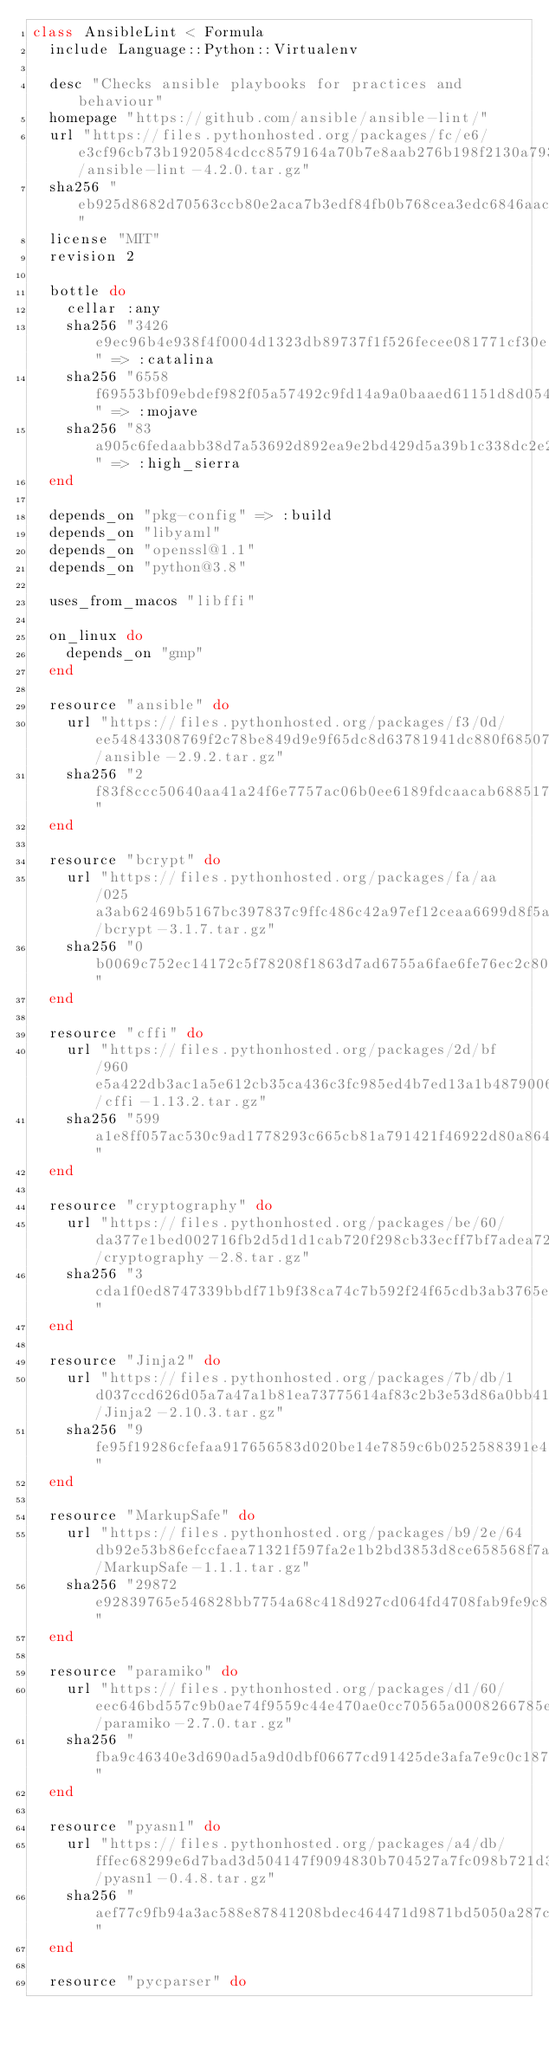Convert code to text. <code><loc_0><loc_0><loc_500><loc_500><_Ruby_>class AnsibleLint < Formula
  include Language::Python::Virtualenv

  desc "Checks ansible playbooks for practices and behaviour"
  homepage "https://github.com/ansible/ansible-lint/"
  url "https://files.pythonhosted.org/packages/fc/e6/e3cf96cb73b1920584cdcc8579164a70b7e8aab276b198f2130a7939efcc/ansible-lint-4.2.0.tar.gz"
  sha256 "eb925d8682d70563ccb80e2aca7b3edf84fb0b768cea3edc6846aac7abdc414a"
  license "MIT"
  revision 2

  bottle do
    cellar :any
    sha256 "3426e9ec96b4e938f4f0004d1323db89737f1f526fecee081771cf30e1689dd7" => :catalina
    sha256 "6558f69553bf09ebdef982f05a57492c9fd14a9a0baaed61151d8d054e652e73" => :mojave
    sha256 "83a905c6fedaabb38d7a53692d892ea9e2bd429d5a39b1c338dc2e26ea0d352f" => :high_sierra
  end

  depends_on "pkg-config" => :build
  depends_on "libyaml"
  depends_on "openssl@1.1"
  depends_on "python@3.8"

  uses_from_macos "libffi"

  on_linux do
    depends_on "gmp"
  end

  resource "ansible" do
    url "https://files.pythonhosted.org/packages/f3/0d/ee54843308769f2c78be849d9e9f65dc8d63781941dc880f68507aae33ba/ansible-2.9.2.tar.gz"
    sha256 "2f83f8ccc50640aa41a24f6e7757ac06b0ee6189fdcaacab68851771d3b42f3a"
  end

  resource "bcrypt" do
    url "https://files.pythonhosted.org/packages/fa/aa/025a3ab62469b5167bc397837c9ffc486c42a97ef12ceaa6699d8f5a5416/bcrypt-3.1.7.tar.gz"
    sha256 "0b0069c752ec14172c5f78208f1863d7ad6755a6fae6fe76ec2c80d13be41e42"
  end

  resource "cffi" do
    url "https://files.pythonhosted.org/packages/2d/bf/960e5a422db3ac1a5e612cb35ca436c3fc985ed4b7ed13a1b4879006f450/cffi-1.13.2.tar.gz"
    sha256 "599a1e8ff057ac530c9ad1778293c665cb81a791421f46922d80a86473c13346"
  end

  resource "cryptography" do
    url "https://files.pythonhosted.org/packages/be/60/da377e1bed002716fb2d5d1d1cab720f298cb33ecff7bf7adea72788e4e4/cryptography-2.8.tar.gz"
    sha256 "3cda1f0ed8747339bbdf71b9f38ca74c7b592f24f65cdb3ab3765e4b02871651"
  end

  resource "Jinja2" do
    url "https://files.pythonhosted.org/packages/7b/db/1d037ccd626d05a7a47a1b81ea73775614af83c2b3e53d86a0bb41d8d799/Jinja2-2.10.3.tar.gz"
    sha256 "9fe95f19286cfefaa917656583d020be14e7859c6b0252588391e47db34527de"
  end

  resource "MarkupSafe" do
    url "https://files.pythonhosted.org/packages/b9/2e/64db92e53b86efccfaea71321f597fa2e1b2bd3853d8ce658568f7a13094/MarkupSafe-1.1.1.tar.gz"
    sha256 "29872e92839765e546828bb7754a68c418d927cd064fd4708fab9fe9c8bb116b"
  end

  resource "paramiko" do
    url "https://files.pythonhosted.org/packages/d1/60/eec646bd557c9b0ae74f9559c44e470ae0cc70565a0008266785eca8e1be/paramiko-2.7.0.tar.gz"
    sha256 "fba9c46340e3d690ad5a9d0dbf06677cd91425de3afa7e9c0c187298ee4ddd0d"
  end

  resource "pyasn1" do
    url "https://files.pythonhosted.org/packages/a4/db/fffec68299e6d7bad3d504147f9094830b704527a7fc098b721d38cc7fa7/pyasn1-0.4.8.tar.gz"
    sha256 "aef77c9fb94a3ac588e87841208bdec464471d9871bd5050a287cc9a475cd0ba"
  end

  resource "pycparser" do</code> 